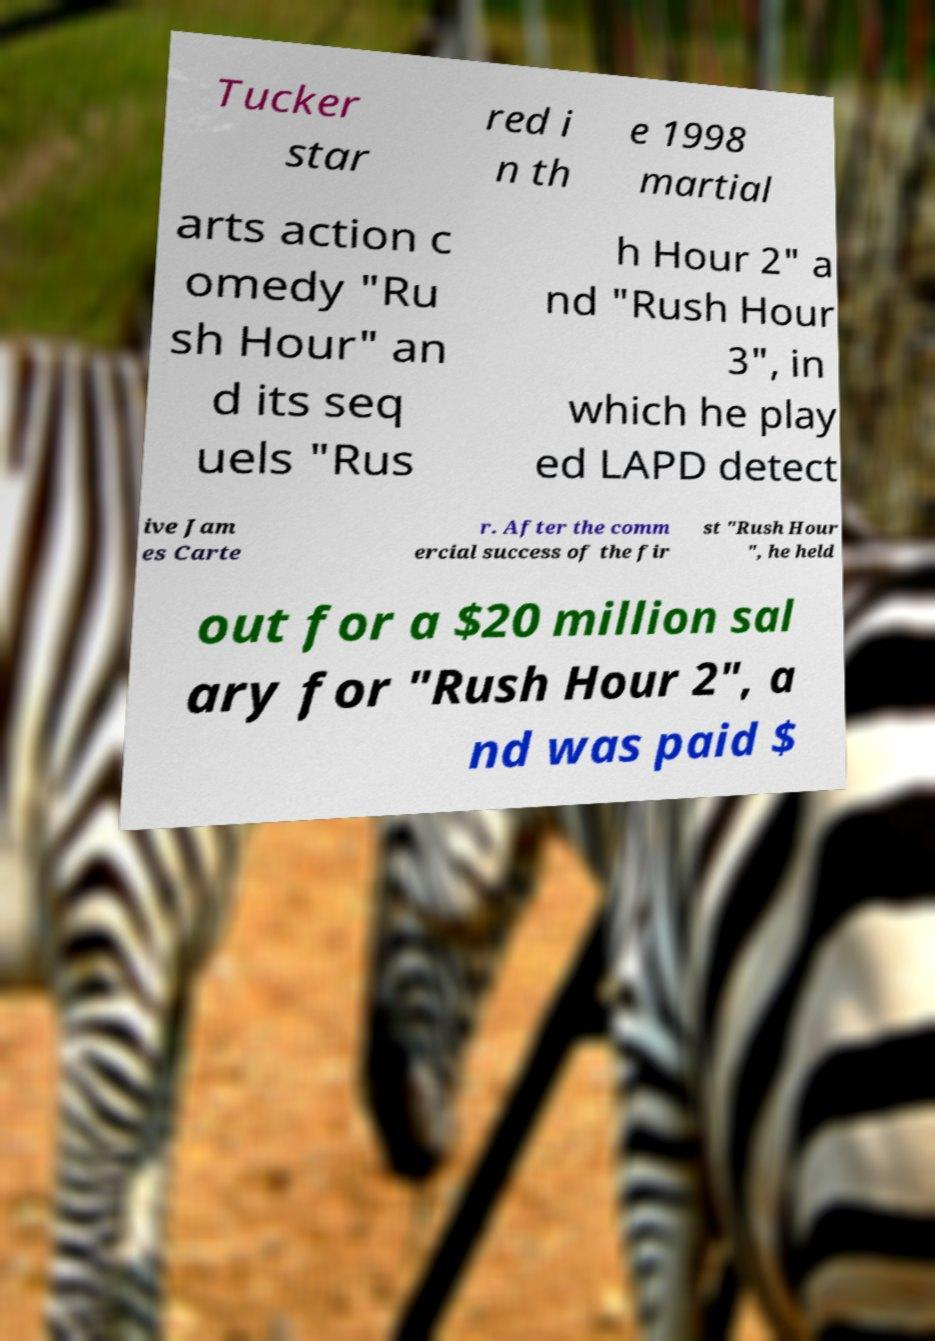Can you read and provide the text displayed in the image?This photo seems to have some interesting text. Can you extract and type it out for me? Tucker star red i n th e 1998 martial arts action c omedy "Ru sh Hour" an d its seq uels "Rus h Hour 2" a nd "Rush Hour 3", in which he play ed LAPD detect ive Jam es Carte r. After the comm ercial success of the fir st "Rush Hour ", he held out for a $20 million sal ary for "Rush Hour 2", a nd was paid $ 